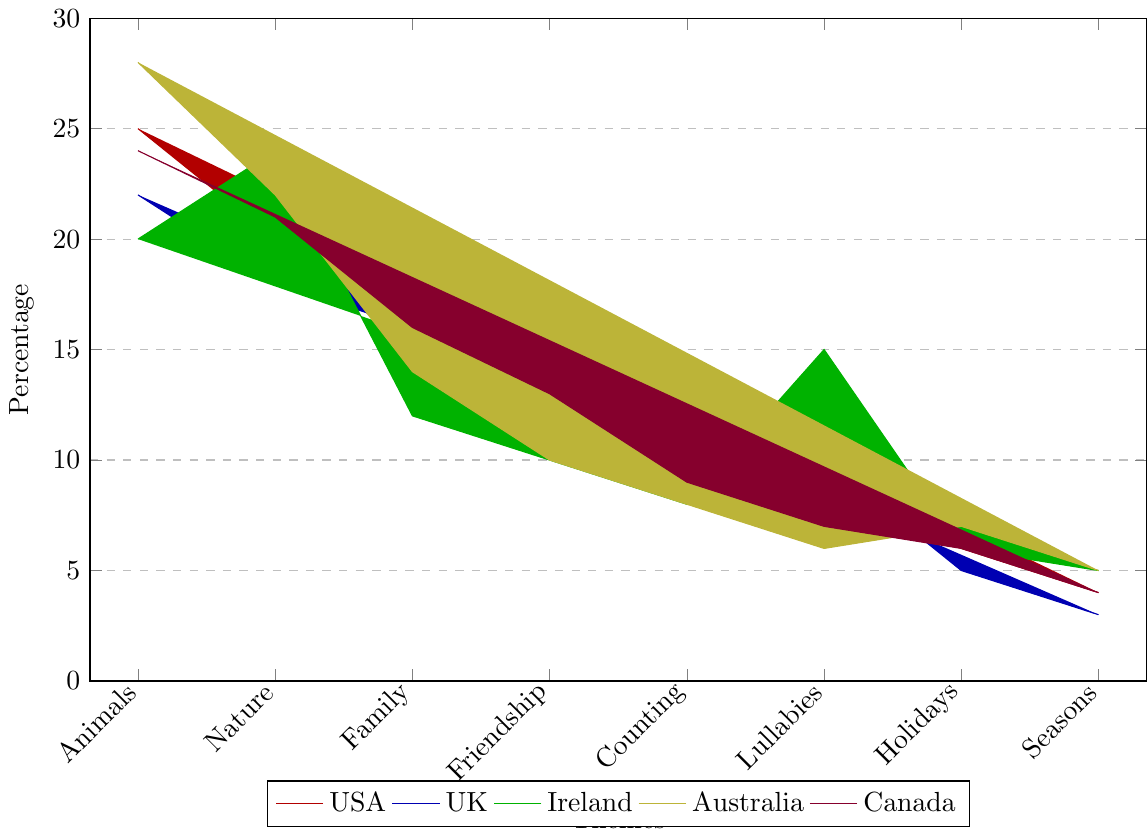Which country has the highest number of 'Animals' themed songs? The bar filled with the highest value for 'Animals' is the yellow bar representing Australia, reaching up to 28.
Answer: Australia Which theme has the lowest number of songs in the USA? The shortest bar for the USA is for the 'Seasons' theme, and its height is 4.
Answer: Seasons Compare the 'Family' themed songs in Germany and Canada. Which country has more? By looking at the two relevant bars, Canada's 'Family' theme bar is taller (16) compared to Germany's (14).
Answer: Canada What's the total number of 'Nature' themed songs from Australia, Ireland, and Sweden? The bars for 'Nature' show Australia with 22, Ireland with 24, and Sweden with 23. Adding these gives 22 + 24 + 23 = 69.
Answer: 69 Are there more 'Lullabies' themed songs in Japan or in France? The height of the 'Lullabies' bar for Japan is 15 while for France it is 14. Thus Japan has more.
Answer: Japan How many more 'Family' themed songs are there in the UK compared to Ireland? The UK has 16 'Family' themed songs while Ireland has 12. The difference is 16 - 12 = 4.
Answer: 4 Which theme has an equal number of songs in Mexico and Spain? Both Mexico and Spain have 7 songs for the 'Holidays' theme bars, which are equally tall.
Answer: Holidays What's the average number of 'Counting' themed songs across the USA, UK, and Canada? Summing 'Counting' themed songs in the USA (10), UK (12), and Canada (9) gives 10 + 12 + 9 = 31. Dividing by 3, the average is 31 / 3 ≈ 10.33.
Answer: 10.33 Does Australia or Brazil have more 'Friendship' themed songs, and by how many? Australia has 10 'Friendship' themed songs, while Brazil has 16. The difference is 16 - 10 = 6.
Answer: Brazil, 6 In which theme does the USA have twice as many songs as Japan? For the 'Seasons' theme, the USA has 4 songs, and Japan has 2 songs. Thus, USA has twice as many.
Answer: Seasons 